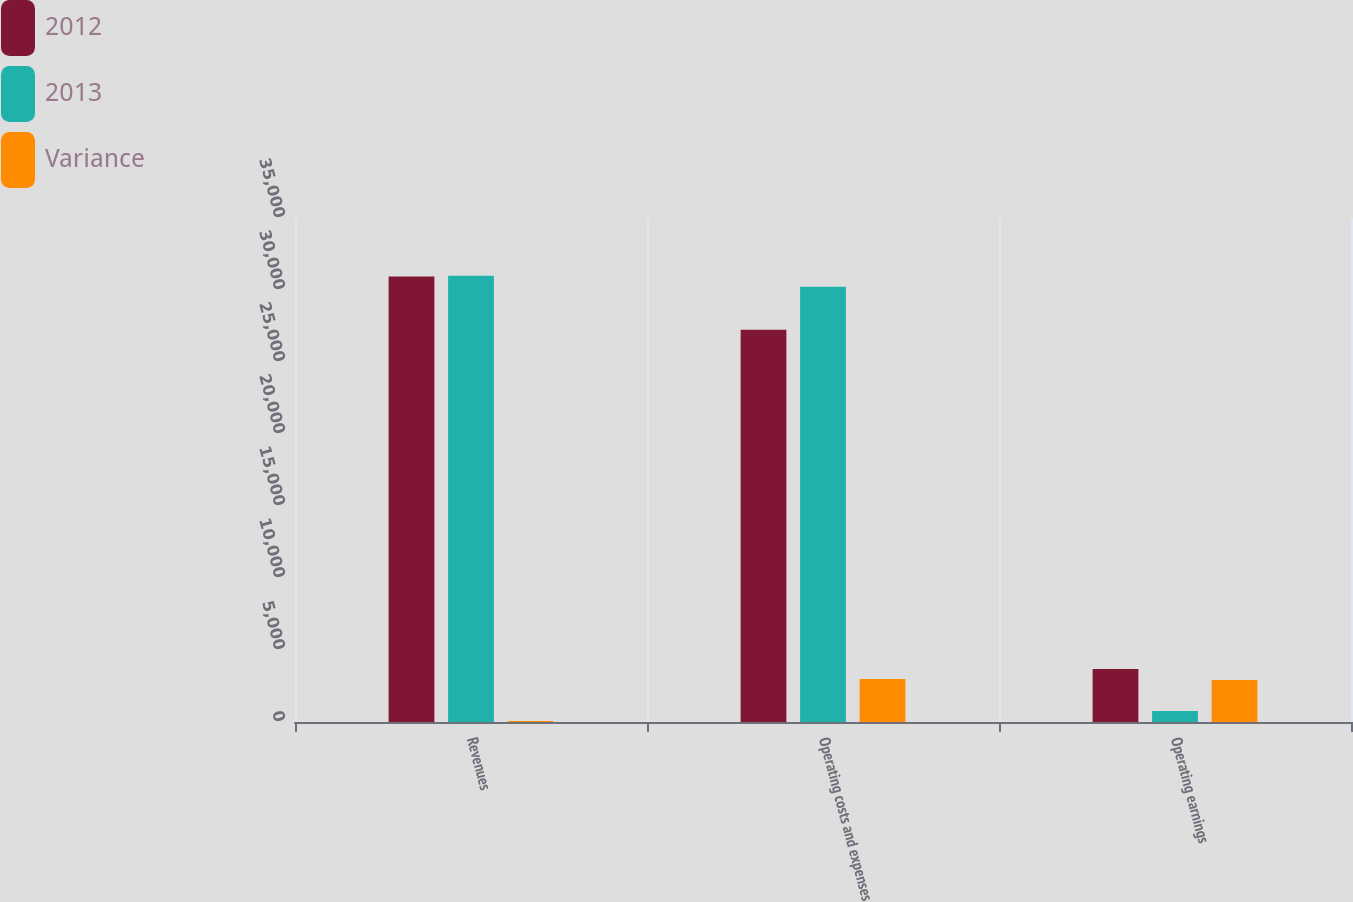Convert chart. <chart><loc_0><loc_0><loc_500><loc_500><stacked_bar_chart><ecel><fcel>Revenues<fcel>Operating costs and expenses<fcel>Operating earnings<nl><fcel>2012<fcel>30930<fcel>27241<fcel>3689<nl><fcel>2013<fcel>30992<fcel>30227<fcel>765<nl><fcel>Variance<fcel>62<fcel>2986<fcel>2924<nl></chart> 